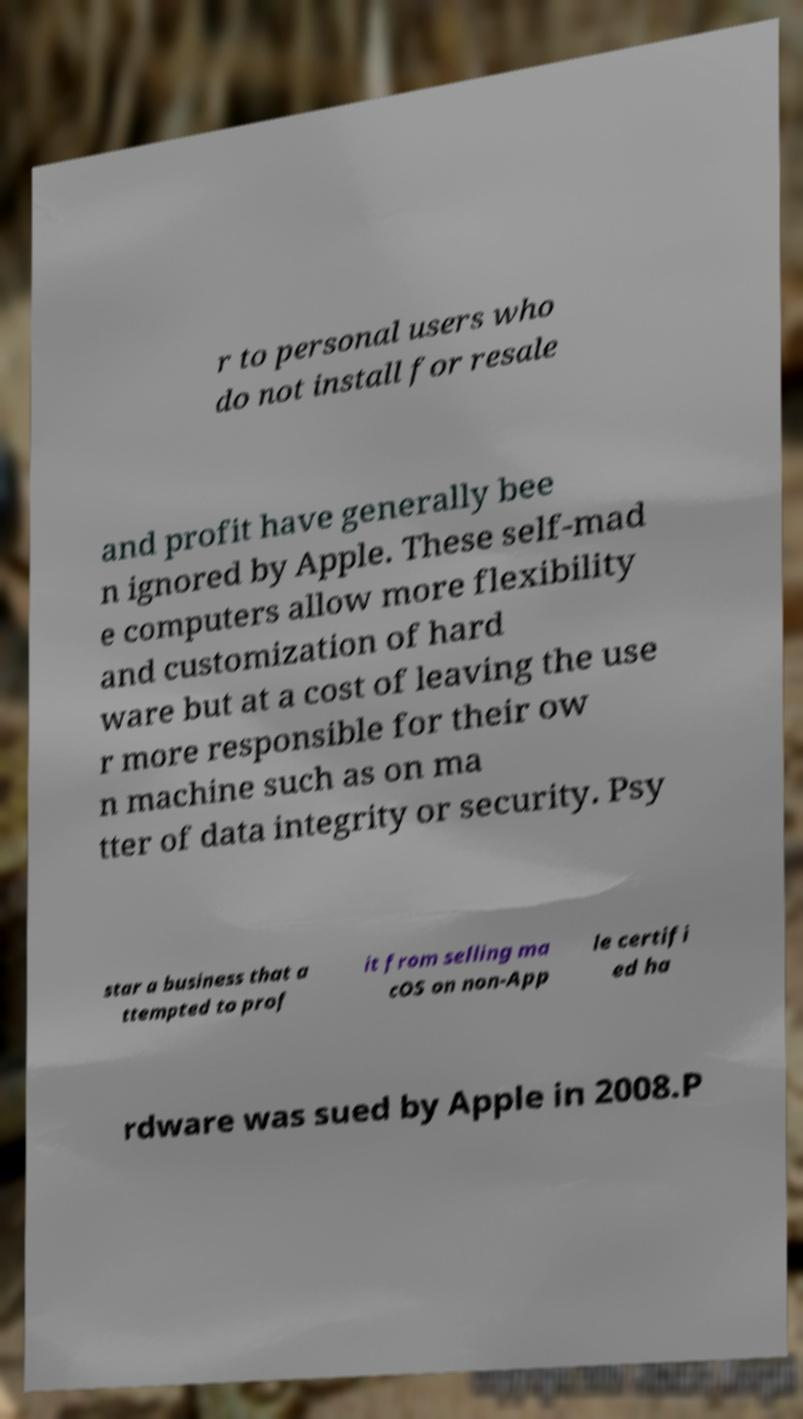I need the written content from this picture converted into text. Can you do that? r to personal users who do not install for resale and profit have generally bee n ignored by Apple. These self-mad e computers allow more flexibility and customization of hard ware but at a cost of leaving the use r more responsible for their ow n machine such as on ma tter of data integrity or security. Psy star a business that a ttempted to prof it from selling ma cOS on non-App le certifi ed ha rdware was sued by Apple in 2008.P 